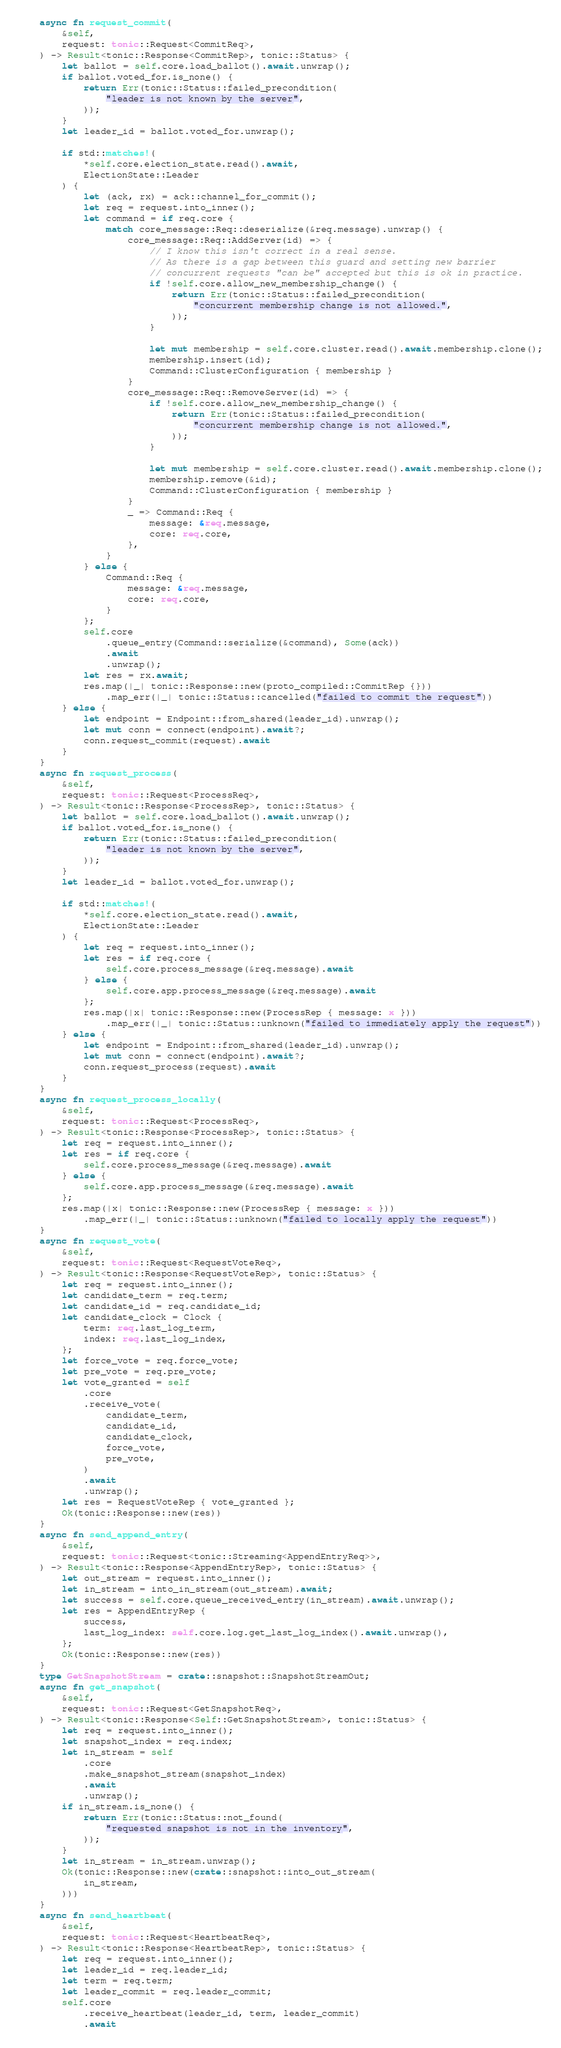Convert code to text. <code><loc_0><loc_0><loc_500><loc_500><_Rust_>    async fn request_commit(
        &self,
        request: tonic::Request<CommitReq>,
    ) -> Result<tonic::Response<CommitRep>, tonic::Status> {
        let ballot = self.core.load_ballot().await.unwrap();
        if ballot.voted_for.is_none() {
            return Err(tonic::Status::failed_precondition(
                "leader is not known by the server",
            ));
        }
        let leader_id = ballot.voted_for.unwrap();

        if std::matches!(
            *self.core.election_state.read().await,
            ElectionState::Leader
        ) {
            let (ack, rx) = ack::channel_for_commit();
            let req = request.into_inner();
            let command = if req.core {
                match core_message::Req::deserialize(&req.message).unwrap() {
                    core_message::Req::AddServer(id) => {
                        // I know this isn't correct in a real sense.
                        // As there is a gap between this guard and setting new barrier
                        // concurrent requests "can be" accepted but this is ok in practice.
                        if !self.core.allow_new_membership_change() {
                            return Err(tonic::Status::failed_precondition(
                                "concurrent membership change is not allowed.",
                            ));
                        }

                        let mut membership = self.core.cluster.read().await.membership.clone();
                        membership.insert(id);
                        Command::ClusterConfiguration { membership }
                    }
                    core_message::Req::RemoveServer(id) => {
                        if !self.core.allow_new_membership_change() {
                            return Err(tonic::Status::failed_precondition(
                                "concurrent membership change is not allowed.",
                            ));
                        }

                        let mut membership = self.core.cluster.read().await.membership.clone();
                        membership.remove(&id);
                        Command::ClusterConfiguration { membership }
                    }
                    _ => Command::Req {
                        message: &req.message,
                        core: req.core,
                    },
                }
            } else {
                Command::Req {
                    message: &req.message,
                    core: req.core,
                }
            };
            self.core
                .queue_entry(Command::serialize(&command), Some(ack))
                .await
                .unwrap();
            let res = rx.await;
            res.map(|_| tonic::Response::new(proto_compiled::CommitRep {}))
                .map_err(|_| tonic::Status::cancelled("failed to commit the request"))
        } else {
            let endpoint = Endpoint::from_shared(leader_id).unwrap();
            let mut conn = connect(endpoint).await?;
            conn.request_commit(request).await
        }
    }
    async fn request_process(
        &self,
        request: tonic::Request<ProcessReq>,
    ) -> Result<tonic::Response<ProcessRep>, tonic::Status> {
        let ballot = self.core.load_ballot().await.unwrap();
        if ballot.voted_for.is_none() {
            return Err(tonic::Status::failed_precondition(
                "leader is not known by the server",
            ));
        }
        let leader_id = ballot.voted_for.unwrap();

        if std::matches!(
            *self.core.election_state.read().await,
            ElectionState::Leader
        ) {
            let req = request.into_inner();
            let res = if req.core {
                self.core.process_message(&req.message).await
            } else {
                self.core.app.process_message(&req.message).await
            };
            res.map(|x| tonic::Response::new(ProcessRep { message: x }))
                .map_err(|_| tonic::Status::unknown("failed to immediately apply the request"))
        } else {
            let endpoint = Endpoint::from_shared(leader_id).unwrap();
            let mut conn = connect(endpoint).await?;
            conn.request_process(request).await
        }
    }
    async fn request_process_locally(
        &self,
        request: tonic::Request<ProcessReq>,
    ) -> Result<tonic::Response<ProcessRep>, tonic::Status> {
        let req = request.into_inner();
        let res = if req.core {
            self.core.process_message(&req.message).await
        } else {
            self.core.app.process_message(&req.message).await
        };
        res.map(|x| tonic::Response::new(ProcessRep { message: x }))
            .map_err(|_| tonic::Status::unknown("failed to locally apply the request"))
    }
    async fn request_vote(
        &self,
        request: tonic::Request<RequestVoteReq>,
    ) -> Result<tonic::Response<RequestVoteRep>, tonic::Status> {
        let req = request.into_inner();
        let candidate_term = req.term;
        let candidate_id = req.candidate_id;
        let candidate_clock = Clock {
            term: req.last_log_term,
            index: req.last_log_index,
        };
        let force_vote = req.force_vote;
        let pre_vote = req.pre_vote;
        let vote_granted = self
            .core
            .receive_vote(
                candidate_term,
                candidate_id,
                candidate_clock,
                force_vote,
                pre_vote,
            )
            .await
            .unwrap();
        let res = RequestVoteRep { vote_granted };
        Ok(tonic::Response::new(res))
    }
    async fn send_append_entry(
        &self,
        request: tonic::Request<tonic::Streaming<AppendEntryReq>>,
    ) -> Result<tonic::Response<AppendEntryRep>, tonic::Status> {
        let out_stream = request.into_inner();
        let in_stream = into_in_stream(out_stream).await;
        let success = self.core.queue_received_entry(in_stream).await.unwrap();
        let res = AppendEntryRep {
            success,
            last_log_index: self.core.log.get_last_log_index().await.unwrap(),
        };
        Ok(tonic::Response::new(res))
    }
    type GetSnapshotStream = crate::snapshot::SnapshotStreamOut;
    async fn get_snapshot(
        &self,
        request: tonic::Request<GetSnapshotReq>,
    ) -> Result<tonic::Response<Self::GetSnapshotStream>, tonic::Status> {
        let req = request.into_inner();
        let snapshot_index = req.index;
        let in_stream = self
            .core
            .make_snapshot_stream(snapshot_index)
            .await
            .unwrap();
        if in_stream.is_none() {
            return Err(tonic::Status::not_found(
                "requested snapshot is not in the inventory",
            ));
        }
        let in_stream = in_stream.unwrap();
        Ok(tonic::Response::new(crate::snapshot::into_out_stream(
            in_stream,
        )))
    }
    async fn send_heartbeat(
        &self,
        request: tonic::Request<HeartbeatReq>,
    ) -> Result<tonic::Response<HeartbeatRep>, tonic::Status> {
        let req = request.into_inner();
        let leader_id = req.leader_id;
        let term = req.term;
        let leader_commit = req.leader_commit;
        self.core
            .receive_heartbeat(leader_id, term, leader_commit)
            .await</code> 